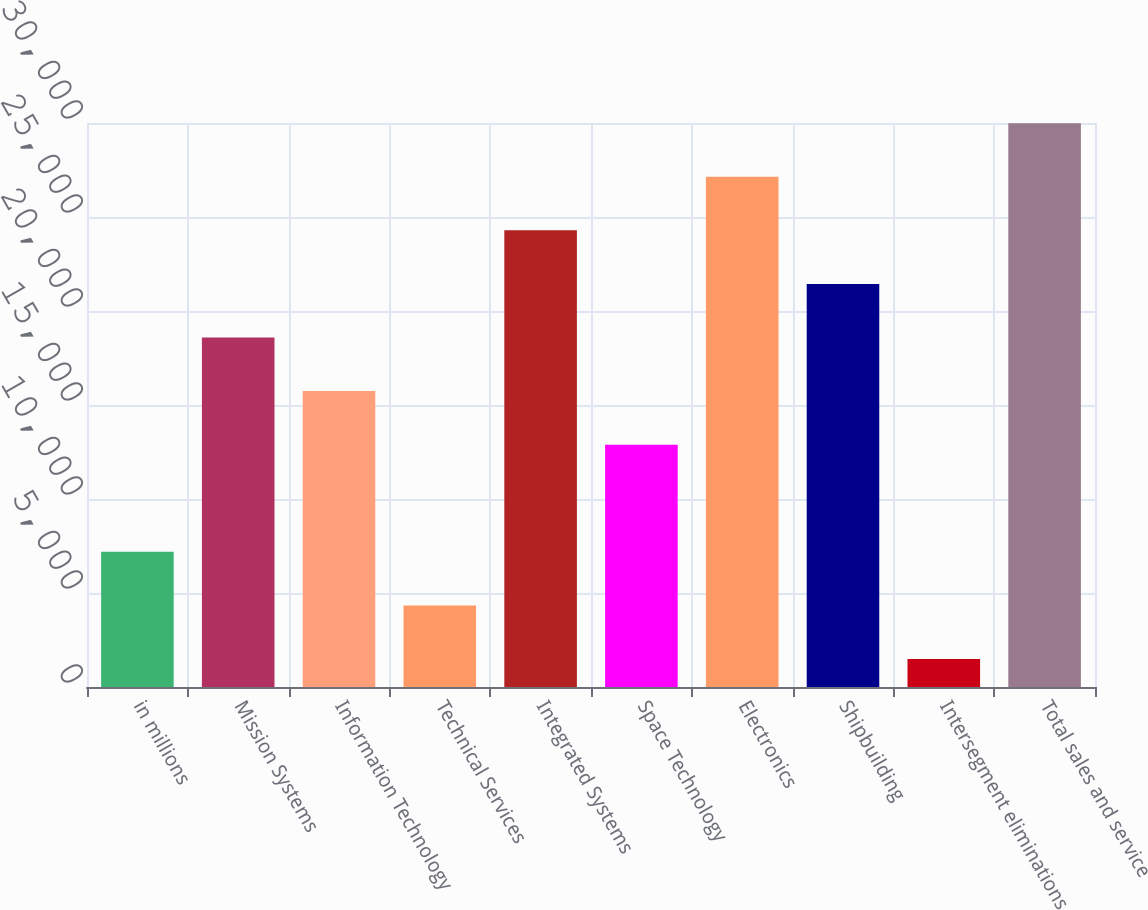<chart> <loc_0><loc_0><loc_500><loc_500><bar_chart><fcel>in millions<fcel>Mission Systems<fcel>Information Technology<fcel>Technical Services<fcel>Integrated Systems<fcel>Space Technology<fcel>Electronics<fcel>Shipbuilding<fcel>Intersegment eliminations<fcel>Total sales and service<nl><fcel>7190.2<fcel>18590.6<fcel>15740.5<fcel>4340.1<fcel>24290.8<fcel>12890.4<fcel>27140.9<fcel>21440.7<fcel>1490<fcel>29991<nl></chart> 